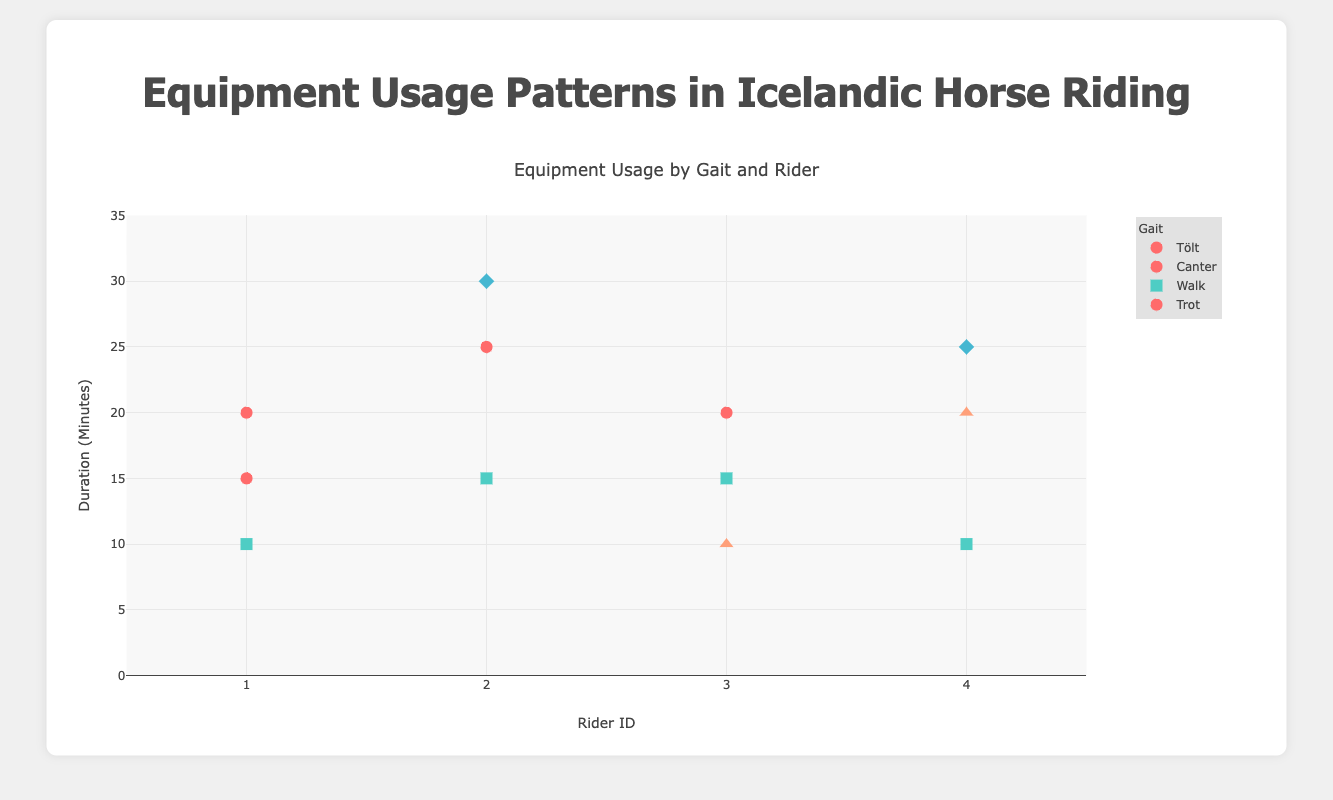What is the title of the figure? The title is displayed at the top of the figure, reflecting the main subject of the data visualization.
Answer: Equipment Usage Patterns in Icelandic Horse Riding What is the range of the y-axis? The y-axis range can be seen along the left side of the plot, listing the minimum and maximum values.
Answer: 0 to 35 minutes How many riders practiced Tölt? By identifying the distinct Rider IDs associated with Tölt markers on the plot, we can determine the count of such riders.
Answer: 3 riders (Rider ID 1, 2, and 4) Which equipment is used the most for Walk gait? Reviewing the legend and markers associated with Walk gait, we count the occurrences of each equipment type.
Answer: Bridle What is the total duration for the rider with RiderID 2 practicing all gaits? Sum the duration times for all gaits practiced by RiderID 2: Tölt (25 + 30) + Walk (15).
Answer: 70 minutes Which horse was ridden with the longest total duration across all gaits? Calculate the total duration for each horse and identify the one with the highest sum.
Answer: Skuggi (70 minutes) Do any riders use different equipment for the same gait? If so, which rider and gait? Check if multiple pieces of equipment are used for a single gait by the same rider by looking at the legend and the corresponding markers for each rider.
Answer: RiderID 2 for Tölt Which gait shows the highest variation in equipment usage? By observing the diversity of marker shapes and colors for each gait on the plot, we assess which gait has the largest variety in equipment.
Answer: Tölt Compare the average duration of the Tölt and Walk for RiderID 1. Which one is longer? Calculate the average duration for Tölt (20 minutes) and Walk (10 minutes) and compare them.
Answer: Tölt (20 minutes) Identify the rider who spent the least time practicing Canter and state the duration. Find the duration for each rider practicing Canter and identify the minimum value.
Answer: Rider ID 1 (15 minutes) 